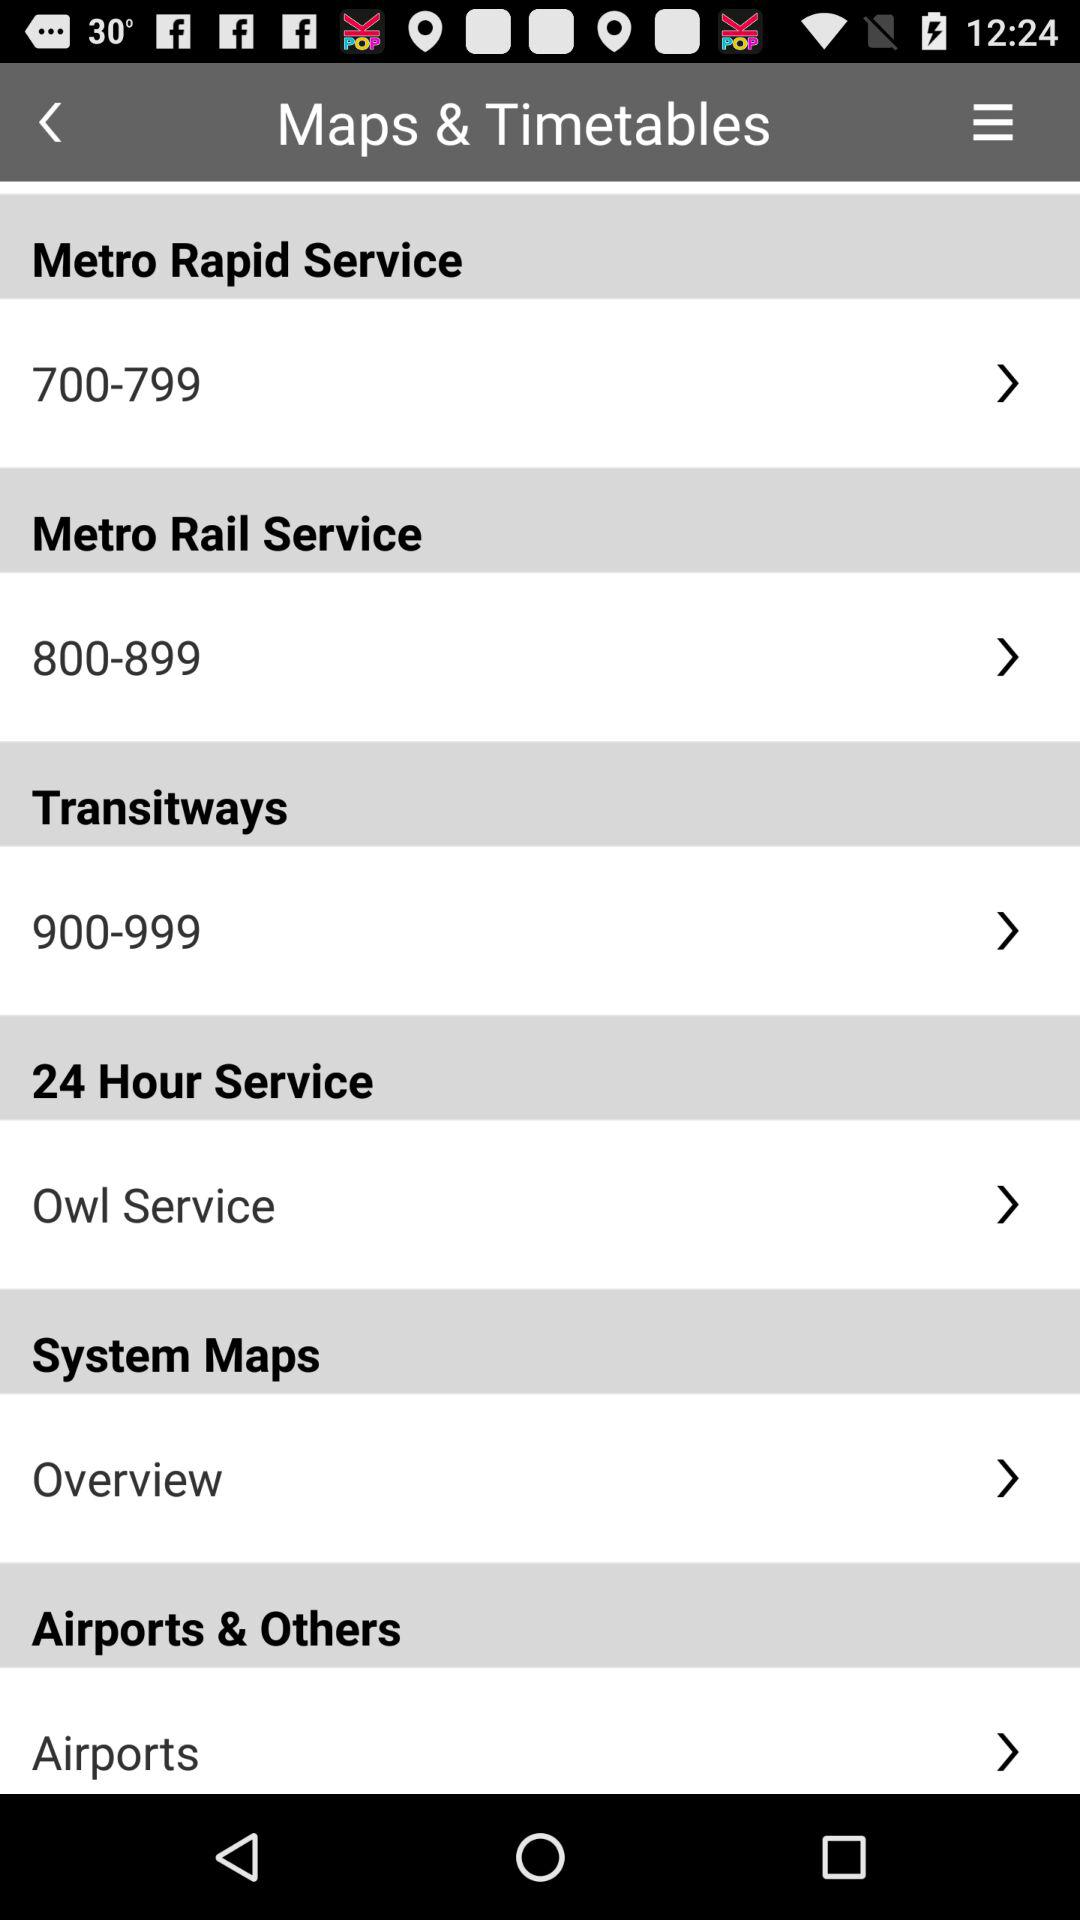For which option "Overview" is selected? "Overview" is selected for "System Maps". 